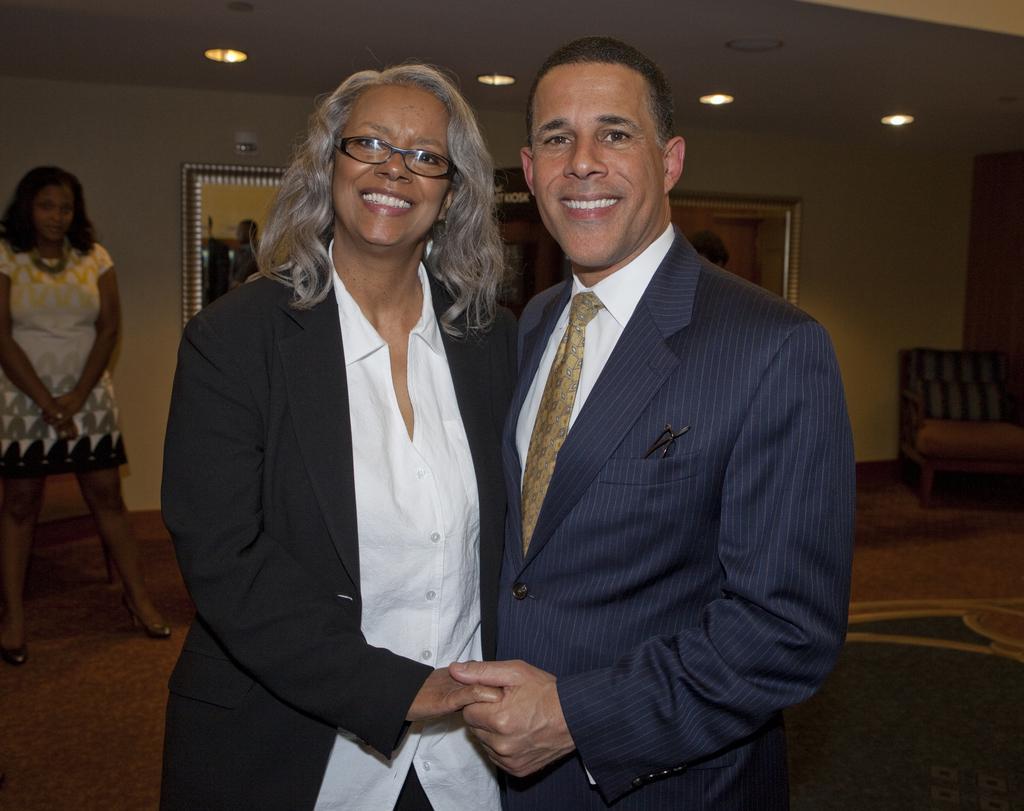Could you give a brief overview of what you see in this image? A lady with black jacket and white shirt is standing and she is smiling. Beside her there is man with blue jacket, white shirt and grey tie. He is smiling. To the left side there is a lady standing. Beside her to the wall there are frames. And to the right side there is a chair. On the top there are lights. 